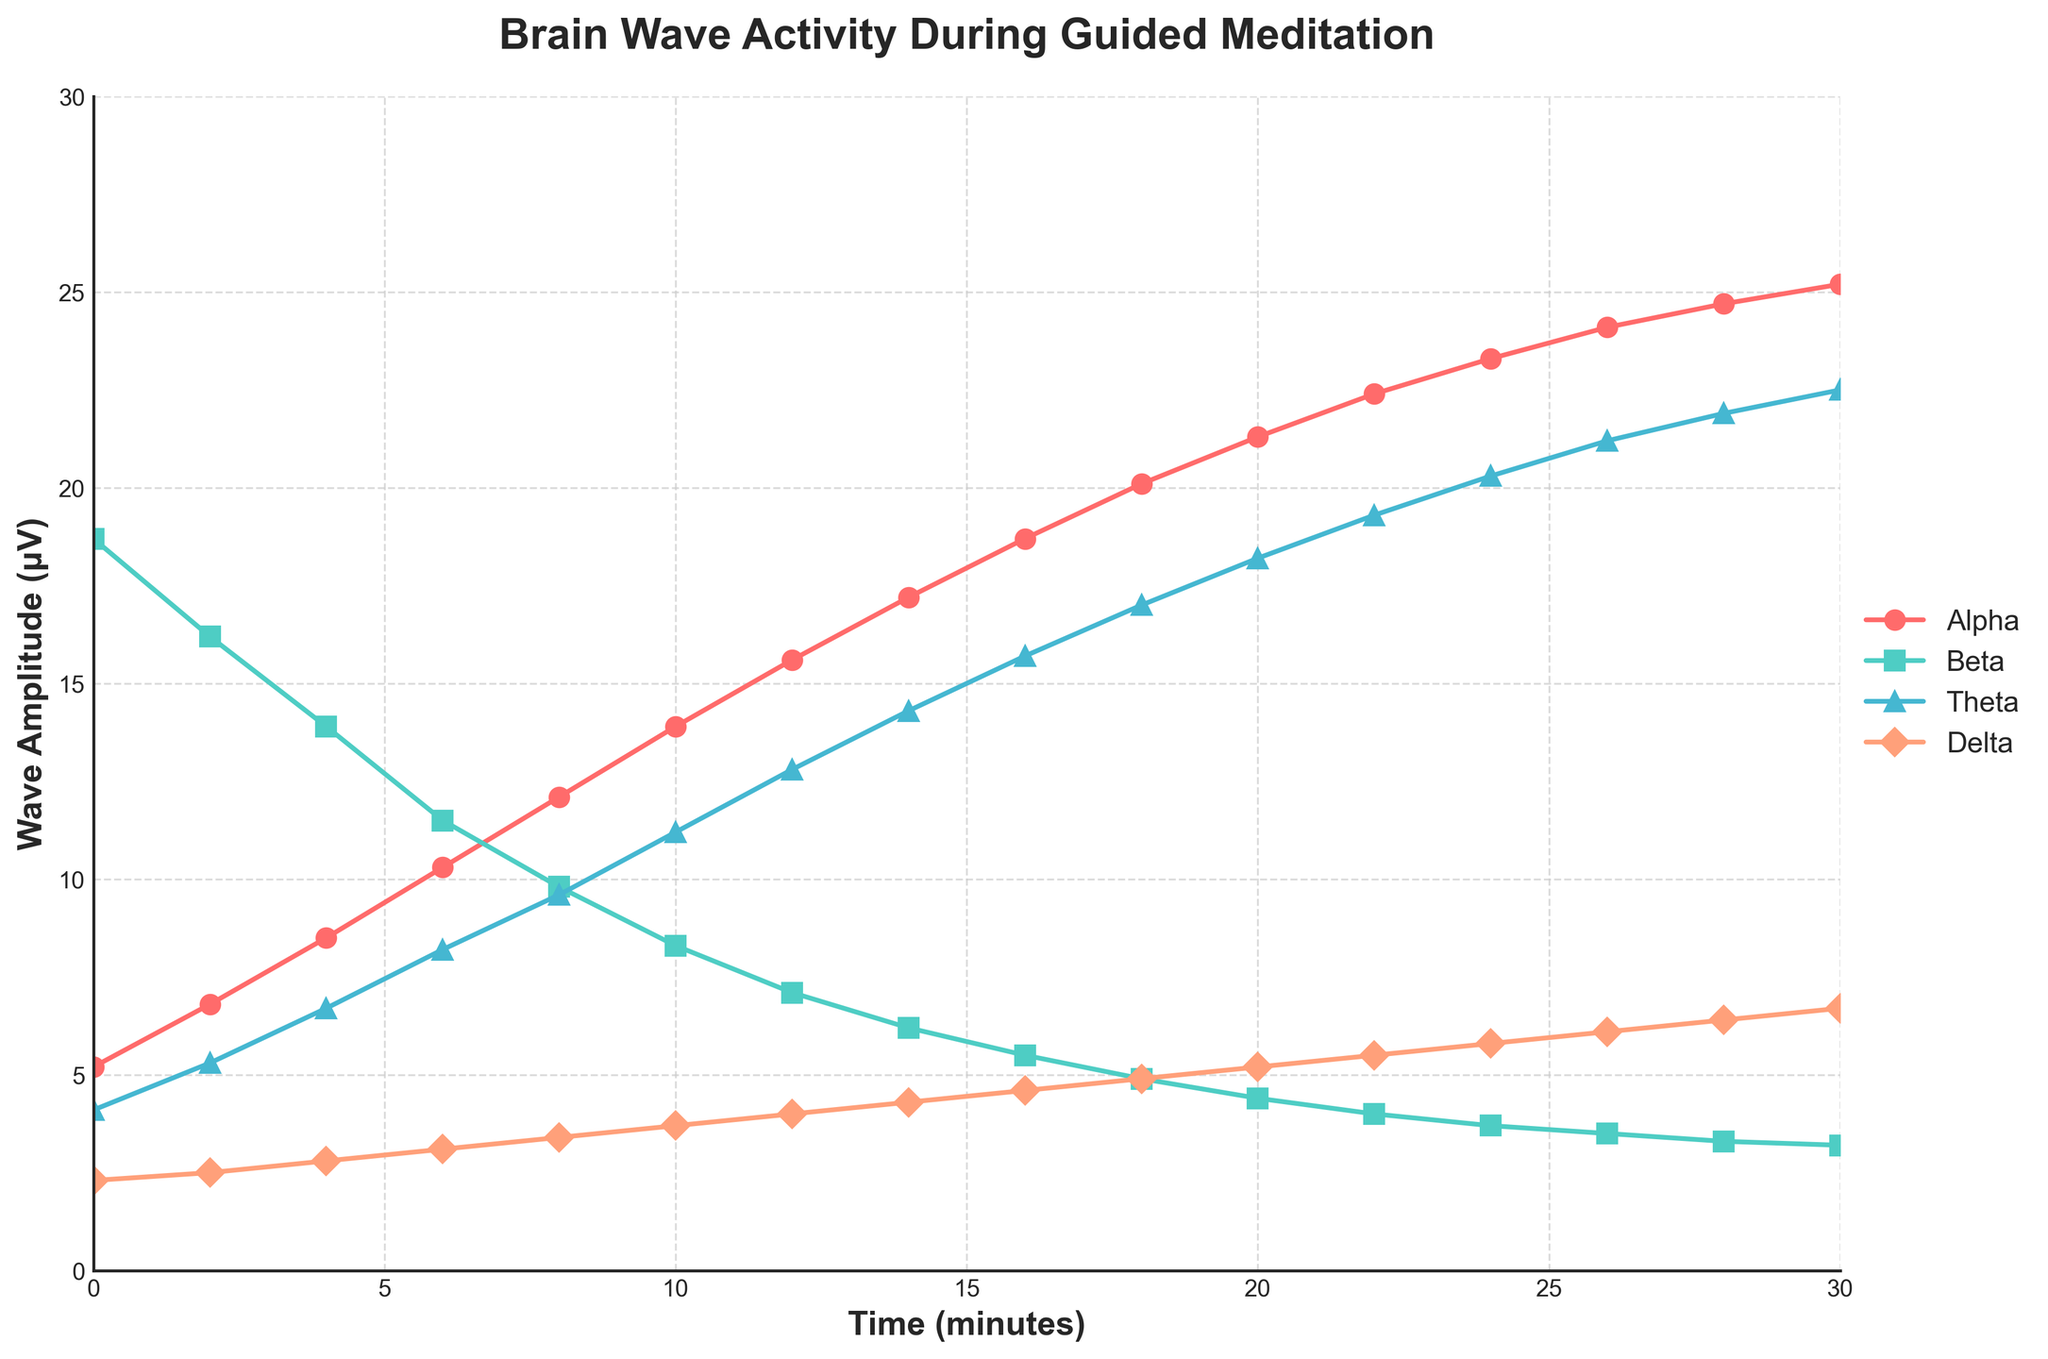What trend is observed in alpha waves over the 30-minute meditation session? To find the trend in alpha waves, observe the line representing alpha waves from the beginning (0 minutes) to the end (30 minutes). Notice that the plot starts at 5.2 μV and steadily increases to 25.2 μV. This indicates a clear upward trend in alpha wave activity over time.
Answer: Steady increase At what time do theta waves exceed 10 μV for the first time? To determine when theta waves first exceed 10 μV, look at the theta wave data points on the chart. The theta waves reach 11.2 μV at 10 minutes, which is the first instance it surpasses 10 μV.
Answer: 10 minutes How do beta waves change between 0 and 10 minutes? To observe how beta waves change between 0 and 10 minutes, find the beta wave points at these times and note their values. Beta waves decrease from 18.7 μV at 0 minutes to 8.3 μV at 10 minutes, showing a clear downward trend.
Answer: Decrease Which type of brain wave shows the smallest change throughout the session? Compare the lines representing each type of brain wave from start to end. Delta waves start at 2.3 μV and end at 6.7 μV, showing the smallest absolute change compared to alpha, beta, and theta waves.
Answer: Delta waves Are there any points where alpha waves and delta waves cross? Analyze the curves representing alpha and delta waves and check if they intersect at any point. From the plot, alpha waves start higher and rise significantly, while delta waves remain much lower, indicating no intersection.
Answer: No At what minute do alpha and theta waves both exceed 20 μV for the first time? First, identify when each wave exceeds 20 μV individually. Alpha waves reach 20 μV at 18 minutes, and theta waves exceed 20 μV at 24 minutes. The earliest time they both exceed 20 μV is 24 minutes.
Answer: 24 minutes Which brain wave type shows the sharpest decline within the given period? Examine the slopes of the lines to evaluate the steepness of decline. Beta waves drop from 18.7 μV to 3.2 μV over 30 minutes, the sharpest decline among all brain waves.
Answer: Beta waves How much do theta waves increase from 0 to 30 minutes, and by how much do beta waves decrease in the same period? Theta waves start at 4.1 μV and end at 22.5 μV, a net increase of 18.4 μV. Beta waves start at 18.7 μV and drop to 3.2 μV, a net decrease of 15.5 μV.
Answer: Theta waves: 18.4 μV, Beta waves: 15.5 μV 